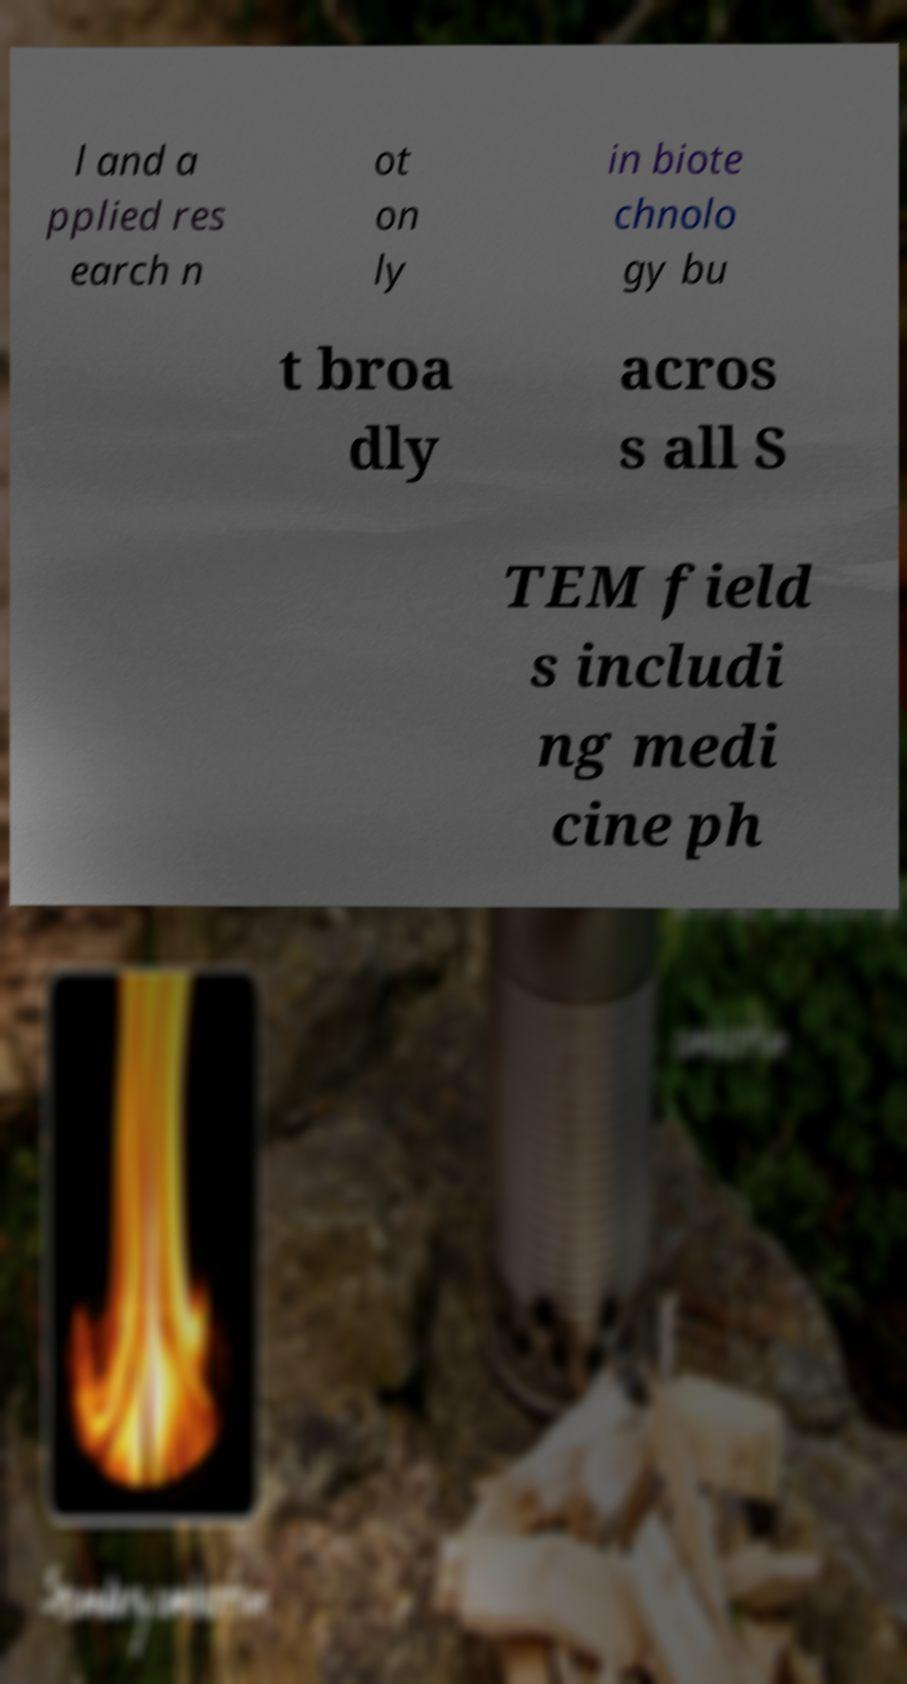Can you read and provide the text displayed in the image?This photo seems to have some interesting text. Can you extract and type it out for me? l and a pplied res earch n ot on ly in biote chnolo gy bu t broa dly acros s all S TEM field s includi ng medi cine ph 